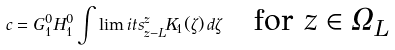Convert formula to latex. <formula><loc_0><loc_0><loc_500><loc_500>c = G _ { 1 } ^ { 0 } H _ { 1 } ^ { 0 } \int \lim i t s _ { z - L } ^ { z } K _ { 1 } ( \zeta ) \, d \zeta \quad \text {for $z \in \Omega_{L}$}</formula> 